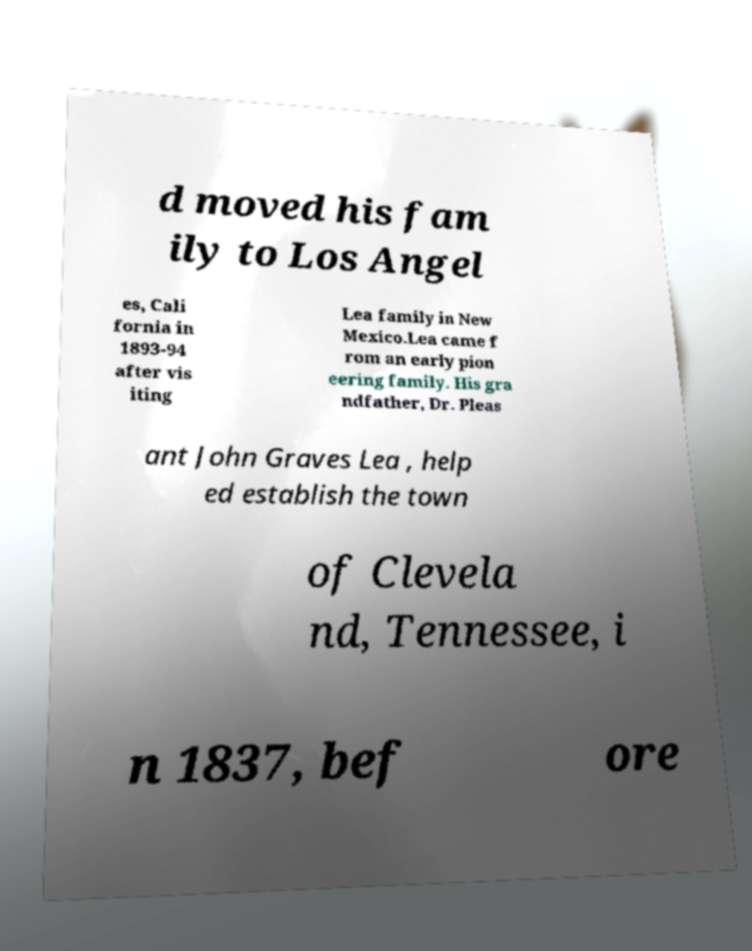Please read and relay the text visible in this image. What does it say? d moved his fam ily to Los Angel es, Cali fornia in 1893-94 after vis iting Lea family in New Mexico.Lea came f rom an early pion eering family. His gra ndfather, Dr. Pleas ant John Graves Lea , help ed establish the town of Clevela nd, Tennessee, i n 1837, bef ore 